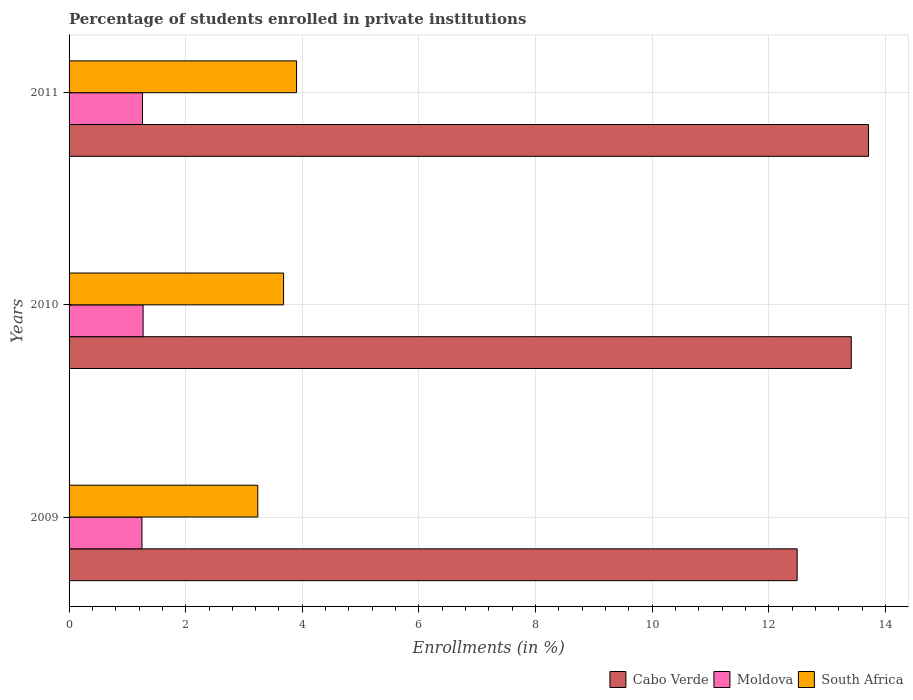How many groups of bars are there?
Offer a very short reply. 3. Are the number of bars on each tick of the Y-axis equal?
Give a very brief answer. Yes. In how many cases, is the number of bars for a given year not equal to the number of legend labels?
Your answer should be very brief. 0. What is the percentage of trained teachers in Cabo Verde in 2009?
Provide a succinct answer. 12.49. Across all years, what is the maximum percentage of trained teachers in South Africa?
Make the answer very short. 3.9. Across all years, what is the minimum percentage of trained teachers in Cabo Verde?
Offer a terse response. 12.49. What is the total percentage of trained teachers in South Africa in the graph?
Make the answer very short. 10.82. What is the difference between the percentage of trained teachers in Cabo Verde in 2009 and that in 2010?
Offer a terse response. -0.93. What is the difference between the percentage of trained teachers in South Africa in 2009 and the percentage of trained teachers in Moldova in 2011?
Make the answer very short. 1.98. What is the average percentage of trained teachers in Moldova per year?
Give a very brief answer. 1.26. In the year 2010, what is the difference between the percentage of trained teachers in South Africa and percentage of trained teachers in Cabo Verde?
Offer a terse response. -9.74. In how many years, is the percentage of trained teachers in Moldova greater than 3.6 %?
Offer a very short reply. 0. What is the ratio of the percentage of trained teachers in Moldova in 2009 to that in 2010?
Make the answer very short. 0.98. Is the percentage of trained teachers in Moldova in 2009 less than that in 2010?
Your response must be concise. Yes. Is the difference between the percentage of trained teachers in South Africa in 2010 and 2011 greater than the difference between the percentage of trained teachers in Cabo Verde in 2010 and 2011?
Provide a succinct answer. Yes. What is the difference between the highest and the second highest percentage of trained teachers in South Africa?
Your response must be concise. 0.22. What is the difference between the highest and the lowest percentage of trained teachers in Moldova?
Your answer should be very brief. 0.02. In how many years, is the percentage of trained teachers in Cabo Verde greater than the average percentage of trained teachers in Cabo Verde taken over all years?
Give a very brief answer. 2. What does the 1st bar from the top in 2010 represents?
Your answer should be very brief. South Africa. What does the 1st bar from the bottom in 2011 represents?
Your answer should be compact. Cabo Verde. Is it the case that in every year, the sum of the percentage of trained teachers in South Africa and percentage of trained teachers in Cabo Verde is greater than the percentage of trained teachers in Moldova?
Offer a very short reply. Yes. How many bars are there?
Your answer should be very brief. 9. Are all the bars in the graph horizontal?
Make the answer very short. Yes. Are the values on the major ticks of X-axis written in scientific E-notation?
Provide a short and direct response. No. How are the legend labels stacked?
Offer a very short reply. Horizontal. What is the title of the graph?
Offer a terse response. Percentage of students enrolled in private institutions. What is the label or title of the X-axis?
Your response must be concise. Enrollments (in %). What is the Enrollments (in %) of Cabo Verde in 2009?
Make the answer very short. 12.49. What is the Enrollments (in %) of Moldova in 2009?
Give a very brief answer. 1.25. What is the Enrollments (in %) in South Africa in 2009?
Your answer should be compact. 3.24. What is the Enrollments (in %) in Cabo Verde in 2010?
Your response must be concise. 13.42. What is the Enrollments (in %) in Moldova in 2010?
Provide a succinct answer. 1.27. What is the Enrollments (in %) in South Africa in 2010?
Your answer should be very brief. 3.68. What is the Enrollments (in %) of Cabo Verde in 2011?
Give a very brief answer. 13.71. What is the Enrollments (in %) of Moldova in 2011?
Your response must be concise. 1.26. What is the Enrollments (in %) of South Africa in 2011?
Provide a short and direct response. 3.9. Across all years, what is the maximum Enrollments (in %) in Cabo Verde?
Ensure brevity in your answer.  13.71. Across all years, what is the maximum Enrollments (in %) of Moldova?
Ensure brevity in your answer.  1.27. Across all years, what is the maximum Enrollments (in %) in South Africa?
Provide a succinct answer. 3.9. Across all years, what is the minimum Enrollments (in %) of Cabo Verde?
Provide a short and direct response. 12.49. Across all years, what is the minimum Enrollments (in %) in Moldova?
Offer a very short reply. 1.25. Across all years, what is the minimum Enrollments (in %) in South Africa?
Give a very brief answer. 3.24. What is the total Enrollments (in %) in Cabo Verde in the graph?
Ensure brevity in your answer.  39.61. What is the total Enrollments (in %) of Moldova in the graph?
Keep it short and to the point. 3.78. What is the total Enrollments (in %) of South Africa in the graph?
Your response must be concise. 10.82. What is the difference between the Enrollments (in %) in Cabo Verde in 2009 and that in 2010?
Provide a short and direct response. -0.93. What is the difference between the Enrollments (in %) of Moldova in 2009 and that in 2010?
Give a very brief answer. -0.02. What is the difference between the Enrollments (in %) in South Africa in 2009 and that in 2010?
Your answer should be compact. -0.44. What is the difference between the Enrollments (in %) of Cabo Verde in 2009 and that in 2011?
Offer a very short reply. -1.22. What is the difference between the Enrollments (in %) of Moldova in 2009 and that in 2011?
Provide a succinct answer. -0.01. What is the difference between the Enrollments (in %) of South Africa in 2009 and that in 2011?
Offer a terse response. -0.66. What is the difference between the Enrollments (in %) in Cabo Verde in 2010 and that in 2011?
Provide a short and direct response. -0.3. What is the difference between the Enrollments (in %) of Moldova in 2010 and that in 2011?
Provide a succinct answer. 0.01. What is the difference between the Enrollments (in %) of South Africa in 2010 and that in 2011?
Your answer should be compact. -0.22. What is the difference between the Enrollments (in %) of Cabo Verde in 2009 and the Enrollments (in %) of Moldova in 2010?
Keep it short and to the point. 11.22. What is the difference between the Enrollments (in %) of Cabo Verde in 2009 and the Enrollments (in %) of South Africa in 2010?
Provide a succinct answer. 8.81. What is the difference between the Enrollments (in %) of Moldova in 2009 and the Enrollments (in %) of South Africa in 2010?
Provide a succinct answer. -2.43. What is the difference between the Enrollments (in %) of Cabo Verde in 2009 and the Enrollments (in %) of Moldova in 2011?
Your answer should be compact. 11.23. What is the difference between the Enrollments (in %) of Cabo Verde in 2009 and the Enrollments (in %) of South Africa in 2011?
Give a very brief answer. 8.59. What is the difference between the Enrollments (in %) in Moldova in 2009 and the Enrollments (in %) in South Africa in 2011?
Provide a succinct answer. -2.65. What is the difference between the Enrollments (in %) of Cabo Verde in 2010 and the Enrollments (in %) of Moldova in 2011?
Give a very brief answer. 12.16. What is the difference between the Enrollments (in %) in Cabo Verde in 2010 and the Enrollments (in %) in South Africa in 2011?
Offer a terse response. 9.51. What is the difference between the Enrollments (in %) in Moldova in 2010 and the Enrollments (in %) in South Africa in 2011?
Offer a very short reply. -2.63. What is the average Enrollments (in %) of Cabo Verde per year?
Offer a terse response. 13.2. What is the average Enrollments (in %) in Moldova per year?
Your response must be concise. 1.26. What is the average Enrollments (in %) of South Africa per year?
Make the answer very short. 3.61. In the year 2009, what is the difference between the Enrollments (in %) of Cabo Verde and Enrollments (in %) of Moldova?
Offer a terse response. 11.24. In the year 2009, what is the difference between the Enrollments (in %) of Cabo Verde and Enrollments (in %) of South Africa?
Provide a succinct answer. 9.25. In the year 2009, what is the difference between the Enrollments (in %) of Moldova and Enrollments (in %) of South Africa?
Offer a very short reply. -1.99. In the year 2010, what is the difference between the Enrollments (in %) of Cabo Verde and Enrollments (in %) of Moldova?
Provide a succinct answer. 12.15. In the year 2010, what is the difference between the Enrollments (in %) of Cabo Verde and Enrollments (in %) of South Africa?
Give a very brief answer. 9.74. In the year 2010, what is the difference between the Enrollments (in %) of Moldova and Enrollments (in %) of South Africa?
Provide a short and direct response. -2.41. In the year 2011, what is the difference between the Enrollments (in %) of Cabo Verde and Enrollments (in %) of Moldova?
Provide a succinct answer. 12.45. In the year 2011, what is the difference between the Enrollments (in %) of Cabo Verde and Enrollments (in %) of South Africa?
Offer a terse response. 9.81. In the year 2011, what is the difference between the Enrollments (in %) of Moldova and Enrollments (in %) of South Africa?
Your answer should be compact. -2.64. What is the ratio of the Enrollments (in %) in Cabo Verde in 2009 to that in 2010?
Keep it short and to the point. 0.93. What is the ratio of the Enrollments (in %) of Moldova in 2009 to that in 2010?
Provide a short and direct response. 0.98. What is the ratio of the Enrollments (in %) in South Africa in 2009 to that in 2010?
Give a very brief answer. 0.88. What is the ratio of the Enrollments (in %) of Cabo Verde in 2009 to that in 2011?
Keep it short and to the point. 0.91. What is the ratio of the Enrollments (in %) in South Africa in 2009 to that in 2011?
Your answer should be very brief. 0.83. What is the ratio of the Enrollments (in %) in Cabo Verde in 2010 to that in 2011?
Your response must be concise. 0.98. What is the ratio of the Enrollments (in %) of Moldova in 2010 to that in 2011?
Provide a succinct answer. 1.01. What is the ratio of the Enrollments (in %) in South Africa in 2010 to that in 2011?
Provide a succinct answer. 0.94. What is the difference between the highest and the second highest Enrollments (in %) in Cabo Verde?
Offer a terse response. 0.3. What is the difference between the highest and the second highest Enrollments (in %) in Moldova?
Provide a short and direct response. 0.01. What is the difference between the highest and the second highest Enrollments (in %) in South Africa?
Offer a very short reply. 0.22. What is the difference between the highest and the lowest Enrollments (in %) of Cabo Verde?
Provide a short and direct response. 1.22. What is the difference between the highest and the lowest Enrollments (in %) of Moldova?
Your answer should be very brief. 0.02. What is the difference between the highest and the lowest Enrollments (in %) of South Africa?
Provide a succinct answer. 0.66. 